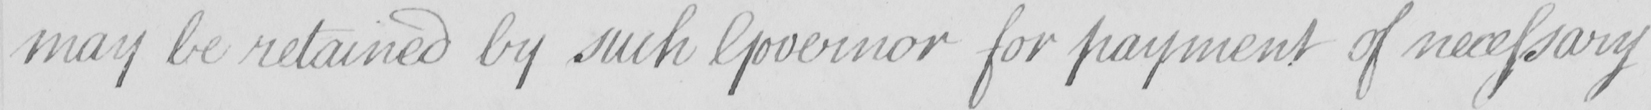Can you tell me what this handwritten text says? may be retained by such Governor for payment of necessary 